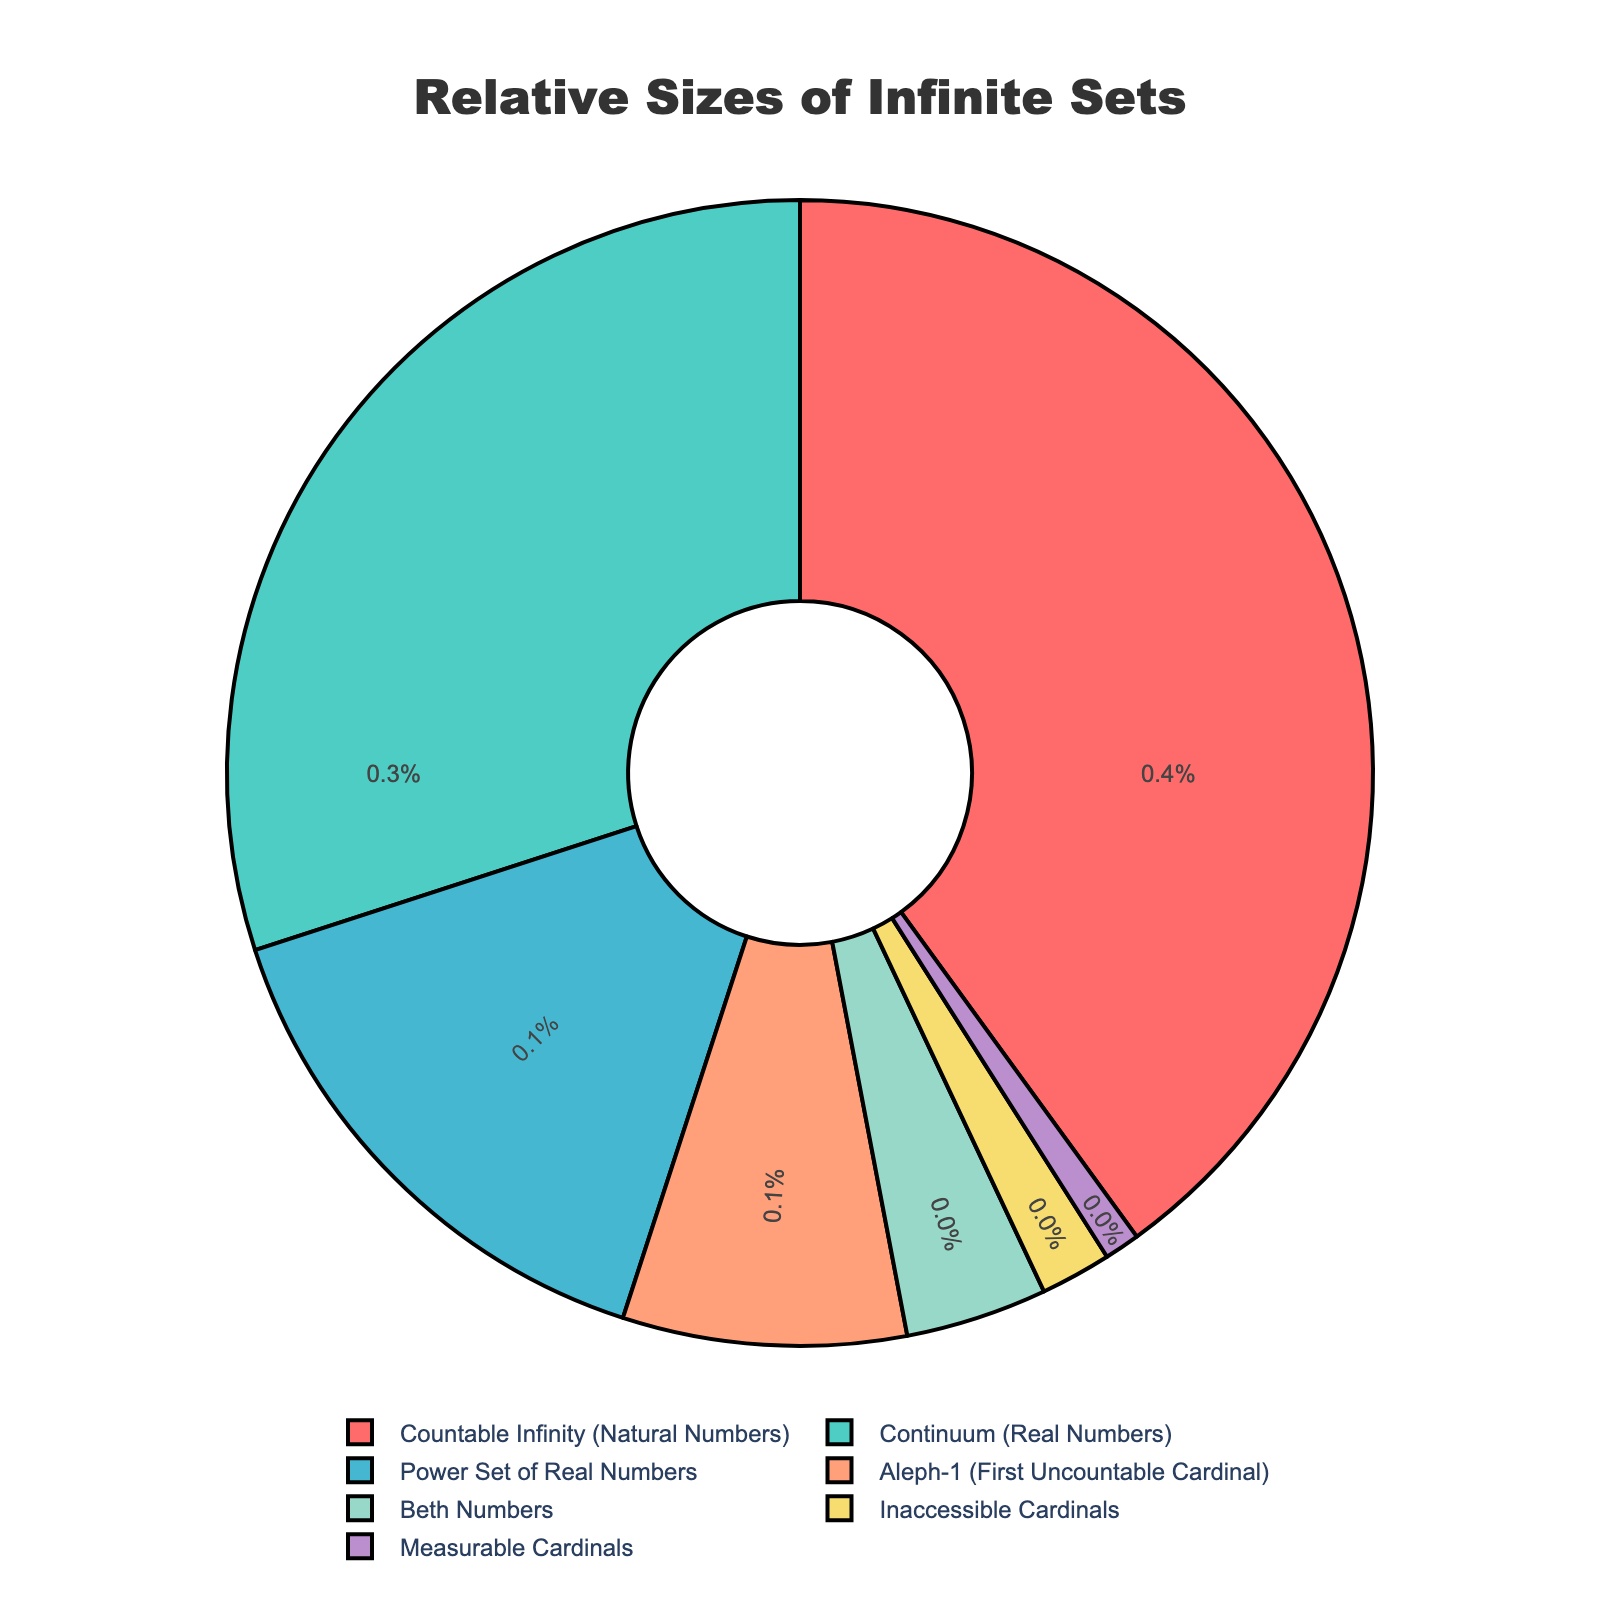What is the largest category by percentage? Look at the section of the pie chart with the largest area. The label "Countable Infinity (Natural Numbers)" is associated with the largest section, and it shows 40%.
Answer: Countable Infinity (Natural Numbers) What is the combined percentage of "Continuum (Real Numbers)" and "Aleph-1 (First Uncountable Cardinal)"? Add the percentages: Continuum (Real Numbers) is 30% and Aleph-1 (First Uncountable Cardinal) is 8%. The sum is 30 + 8 = 38%.
Answer: 38% Which category has a smaller percentage: "Beth Numbers" or "Inaccessible Cardinals"? Compare the percentages labeled on the sections: Beth Numbers is 4% and Inaccessible Cardinals is 2%. Since 4% is greater than 2%, Inaccessible Cardinals has the smaller percentage.
Answer: Inaccessible Cardinals What is the percentage difference between the "Power Set of Real Numbers" and "Measurable Cardinals"? Subtract the smaller percentage from the larger: Power Set of Real Numbers is 15% and Measurable Cardinals is 1%. So, 15 - 1 = 14%.
Answer: 14% What color represents "Continuum (Real Numbers)" on the pie chart? Observe the color associated with the "Continuum (Real Numbers)" label on the pie chart. It is shown in green.
Answer: Green Which is larger: the percentage of "Aleph-1 (First Uncountable Cardinal)" or "Beth Numbers"? Compare the two percentages: Aleph-1 (First Uncountable Cardinal) is 8% and Beth Numbers is 4%. Since 8% is greater than 4%, Aleph-1 (First Uncountable Cardinal) is larger.
Answer: Aleph-1 (First Uncountable Cardinal) What is the sum of all percentages for categories with less than 10%? Add the percentages of the categories with less than 10%: Aleph-1 (First Uncountable Cardinal) is 8%, Beth Numbers is 4%, Inaccessible Cardinals is 2%, and Measurable Cardinals is 1%. The sum is 8 + 4 + 2 + 1 = 15%.
Answer: 15% Which category is represented by the purple color? Identify which label is associated with the purple color section. The category labeled as "Power Set of Real Numbers" is shown in purple.
Answer: Power Set of Real Numbers By how much does the percentage of "Countable Infinity (Natural Numbers)" exceed that of "Continuum (Real Numbers)"? Subtract the smaller percentage from the larger: Countable Infinity (Natural Numbers) is 40% and Continuum (Real Numbers) is 30%. So, 40 - 30 = 10%.
Answer: 10% What are the percentages of the three smallest categories combined? Sum the percentages of the three categories with the smallest values: Inaccessible Cardinals is 2%, Measurable Cardinals is 1%, and Beth Numbers is 4%. The sum is 2 + 1 + 4 = 7%.
Answer: 7% 